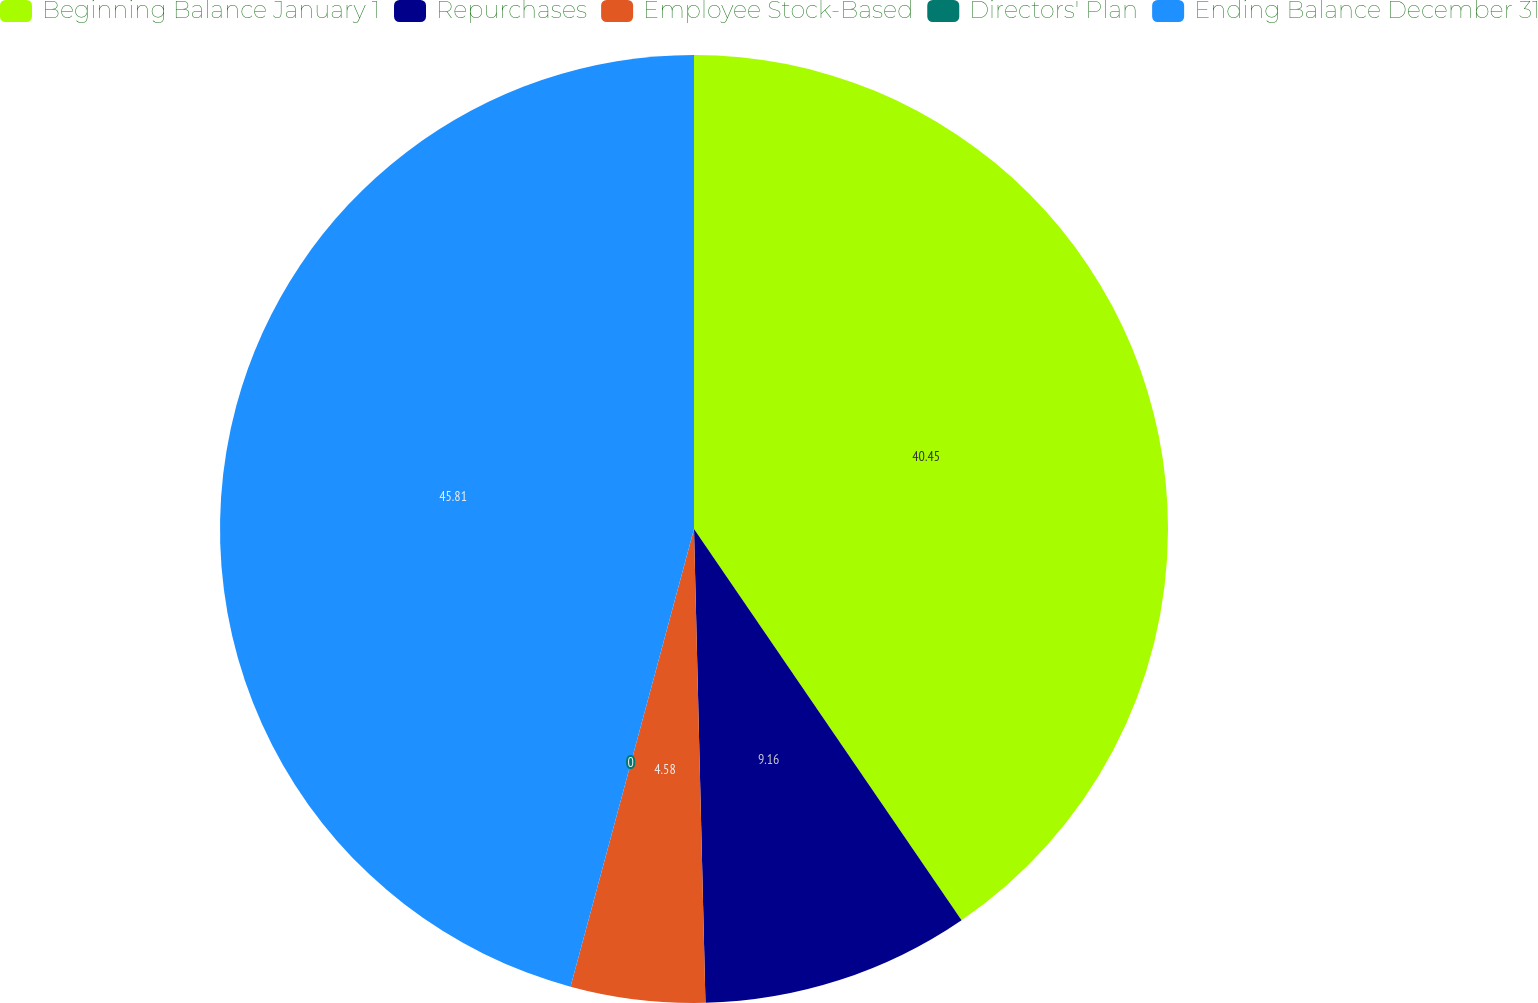<chart> <loc_0><loc_0><loc_500><loc_500><pie_chart><fcel>Beginning Balance January 1<fcel>Repurchases<fcel>Employee Stock-Based<fcel>Directors' Plan<fcel>Ending Balance December 31<nl><fcel>40.45%<fcel>9.16%<fcel>4.58%<fcel>0.0%<fcel>45.8%<nl></chart> 